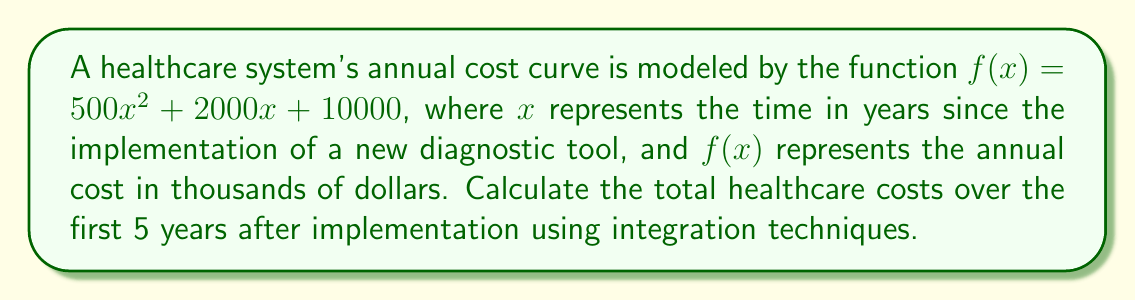Can you answer this question? To find the total healthcare costs over the first 5 years, we need to calculate the area under the curve $f(x)$ from $x=0$ to $x=5$. This can be done using definite integration.

1) Set up the definite integral:
   $$\int_0^5 (500x^2 + 2000x + 10000) dx$$

2) Integrate the function:
   $$\left[\frac{500x^3}{3} + 1000x^2 + 10000x\right]_0^5$$

3) Evaluate the integral at the upper and lower bounds:
   $$\left(\frac{500(5^3)}{3} + 1000(5^2) + 10000(5)\right) - \left(\frac{500(0^3)}{3} + 1000(0^2) + 10000(0)\right)$$

4) Simplify:
   $$\left(\frac{62500}{3} + 25000 + 50000\right) - (0)$$
   $$\approx 95833.33 + 25000 + 50000$$
   $$= 170833.33$$

5) Interpret the result:
   The total cost over 5 years is approximately 170,833.33 thousand dollars, or $170,833,330.
Answer: $170,833,330 